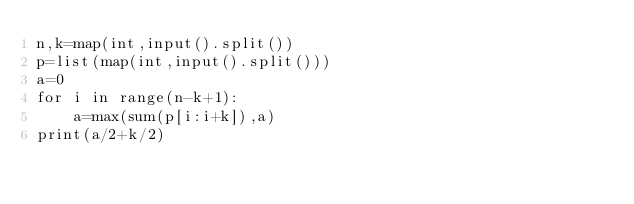<code> <loc_0><loc_0><loc_500><loc_500><_Python_>n,k=map(int,input().split())
p=list(map(int,input().split()))
a=0
for i in range(n-k+1):
    a=max(sum(p[i:i+k]),a)
print(a/2+k/2)
</code> 